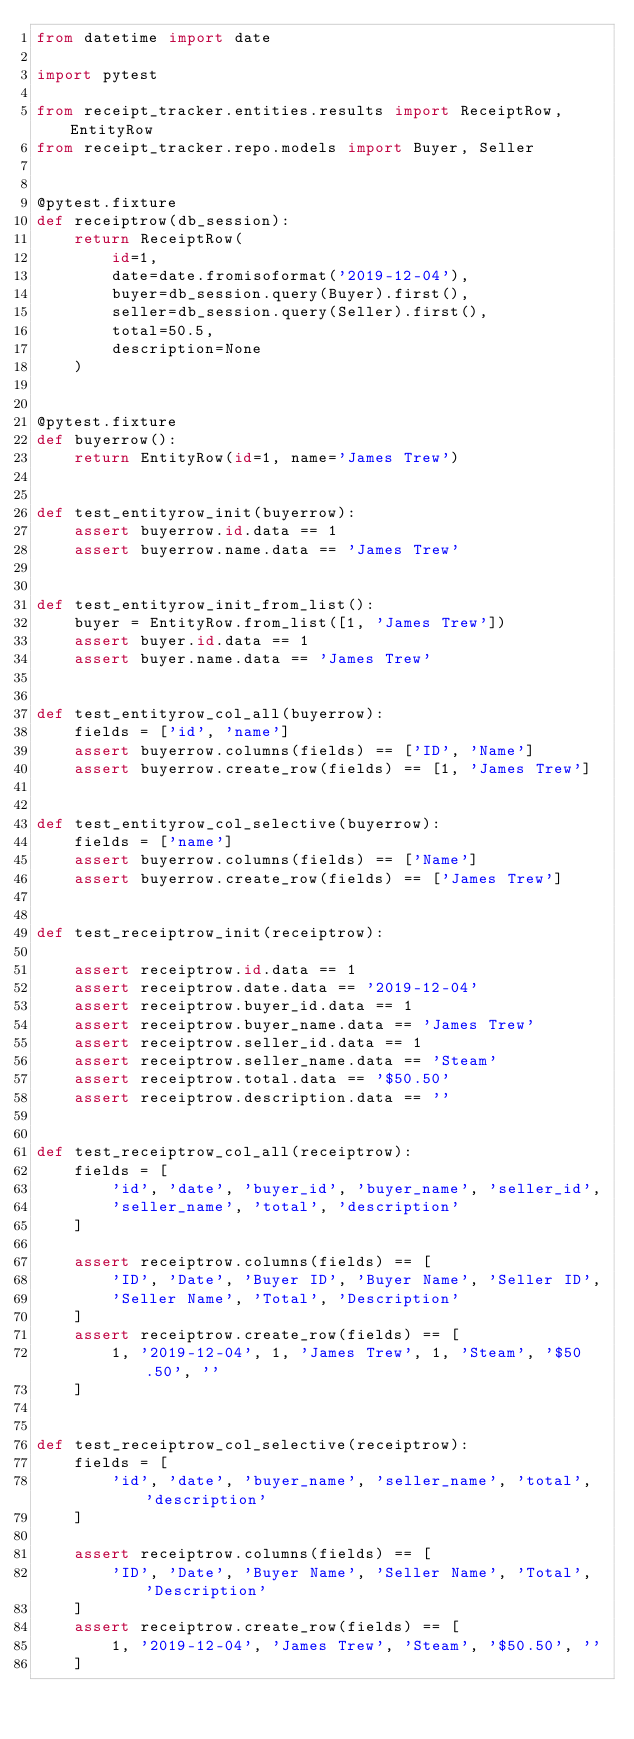Convert code to text. <code><loc_0><loc_0><loc_500><loc_500><_Python_>from datetime import date

import pytest

from receipt_tracker.entities.results import ReceiptRow, EntityRow
from receipt_tracker.repo.models import Buyer, Seller


@pytest.fixture
def receiptrow(db_session):
    return ReceiptRow(
        id=1,
        date=date.fromisoformat('2019-12-04'),
        buyer=db_session.query(Buyer).first(),
        seller=db_session.query(Seller).first(),
        total=50.5,
        description=None
    )


@pytest.fixture
def buyerrow():
    return EntityRow(id=1, name='James Trew')


def test_entityrow_init(buyerrow):
    assert buyerrow.id.data == 1
    assert buyerrow.name.data == 'James Trew'


def test_entityrow_init_from_list():
    buyer = EntityRow.from_list([1, 'James Trew'])
    assert buyer.id.data == 1
    assert buyer.name.data == 'James Trew'


def test_entityrow_col_all(buyerrow):
    fields = ['id', 'name']
    assert buyerrow.columns(fields) == ['ID', 'Name']
    assert buyerrow.create_row(fields) == [1, 'James Trew']


def test_entityrow_col_selective(buyerrow):
    fields = ['name']
    assert buyerrow.columns(fields) == ['Name']
    assert buyerrow.create_row(fields) == ['James Trew']


def test_receiptrow_init(receiptrow):

    assert receiptrow.id.data == 1
    assert receiptrow.date.data == '2019-12-04'
    assert receiptrow.buyer_id.data == 1
    assert receiptrow.buyer_name.data == 'James Trew'
    assert receiptrow.seller_id.data == 1
    assert receiptrow.seller_name.data == 'Steam'
    assert receiptrow.total.data == '$50.50'
    assert receiptrow.description.data == ''


def test_receiptrow_col_all(receiptrow):
    fields = [
        'id', 'date', 'buyer_id', 'buyer_name', 'seller_id',
        'seller_name', 'total', 'description'
    ]

    assert receiptrow.columns(fields) == [
        'ID', 'Date', 'Buyer ID', 'Buyer Name', 'Seller ID',
        'Seller Name', 'Total', 'Description'
    ]
    assert receiptrow.create_row(fields) == [
        1, '2019-12-04', 1, 'James Trew', 1, 'Steam', '$50.50', ''
    ]


def test_receiptrow_col_selective(receiptrow):
    fields = [
        'id', 'date', 'buyer_name', 'seller_name', 'total', 'description'
    ]

    assert receiptrow.columns(fields) == [
        'ID', 'Date', 'Buyer Name', 'Seller Name', 'Total', 'Description'
    ]
    assert receiptrow.create_row(fields) == [
        1, '2019-12-04', 'James Trew', 'Steam', '$50.50', ''
    ]
</code> 